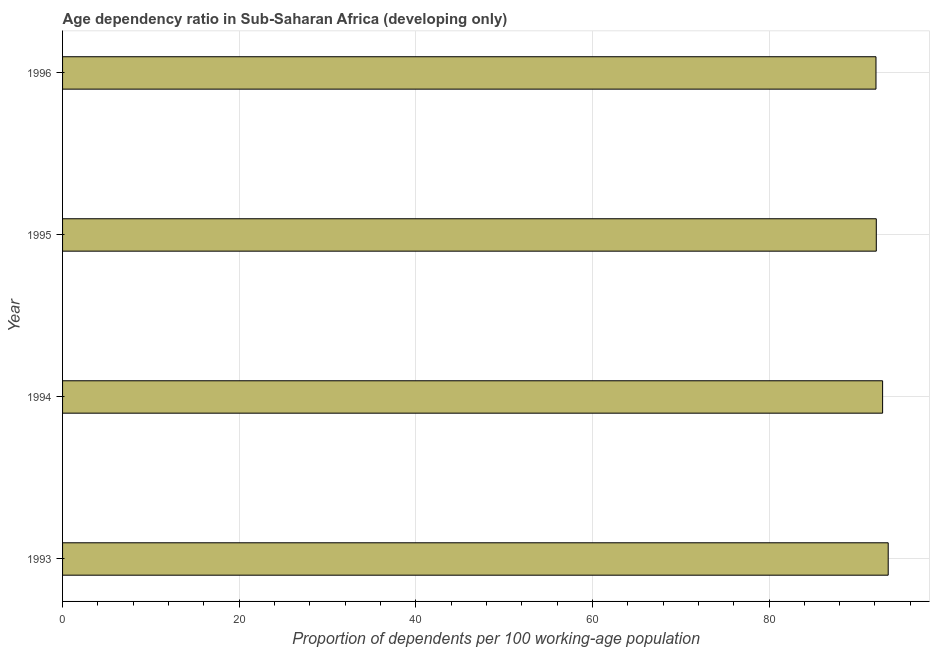Does the graph contain any zero values?
Your answer should be compact. No. Does the graph contain grids?
Give a very brief answer. Yes. What is the title of the graph?
Your response must be concise. Age dependency ratio in Sub-Saharan Africa (developing only). What is the label or title of the X-axis?
Your response must be concise. Proportion of dependents per 100 working-age population. What is the label or title of the Y-axis?
Offer a terse response. Year. What is the age dependency ratio in 1994?
Provide a succinct answer. 92.87. Across all years, what is the maximum age dependency ratio?
Keep it short and to the point. 93.5. Across all years, what is the minimum age dependency ratio?
Offer a very short reply. 92.11. In which year was the age dependency ratio maximum?
Provide a short and direct response. 1993. In which year was the age dependency ratio minimum?
Keep it short and to the point. 1996. What is the sum of the age dependency ratio?
Your answer should be very brief. 370.63. What is the difference between the age dependency ratio in 1993 and 1995?
Make the answer very short. 1.35. What is the average age dependency ratio per year?
Make the answer very short. 92.66. What is the median age dependency ratio?
Ensure brevity in your answer.  92.51. In how many years, is the age dependency ratio greater than 32 ?
Provide a short and direct response. 4. Is the age dependency ratio in 1993 less than that in 1995?
Your answer should be compact. No. What is the difference between the highest and the second highest age dependency ratio?
Give a very brief answer. 0.64. What is the difference between the highest and the lowest age dependency ratio?
Make the answer very short. 1.39. How many bars are there?
Make the answer very short. 4. Are all the bars in the graph horizontal?
Offer a terse response. Yes. Are the values on the major ticks of X-axis written in scientific E-notation?
Your answer should be very brief. No. What is the Proportion of dependents per 100 working-age population of 1993?
Your answer should be very brief. 93.5. What is the Proportion of dependents per 100 working-age population in 1994?
Provide a succinct answer. 92.87. What is the Proportion of dependents per 100 working-age population in 1995?
Provide a succinct answer. 92.15. What is the Proportion of dependents per 100 working-age population of 1996?
Provide a short and direct response. 92.11. What is the difference between the Proportion of dependents per 100 working-age population in 1993 and 1994?
Provide a succinct answer. 0.63. What is the difference between the Proportion of dependents per 100 working-age population in 1993 and 1995?
Keep it short and to the point. 1.35. What is the difference between the Proportion of dependents per 100 working-age population in 1993 and 1996?
Your answer should be compact. 1.39. What is the difference between the Proportion of dependents per 100 working-age population in 1994 and 1995?
Provide a short and direct response. 0.71. What is the difference between the Proportion of dependents per 100 working-age population in 1994 and 1996?
Give a very brief answer. 0.75. What is the difference between the Proportion of dependents per 100 working-age population in 1995 and 1996?
Offer a terse response. 0.04. What is the ratio of the Proportion of dependents per 100 working-age population in 1993 to that in 1995?
Offer a very short reply. 1.01. 